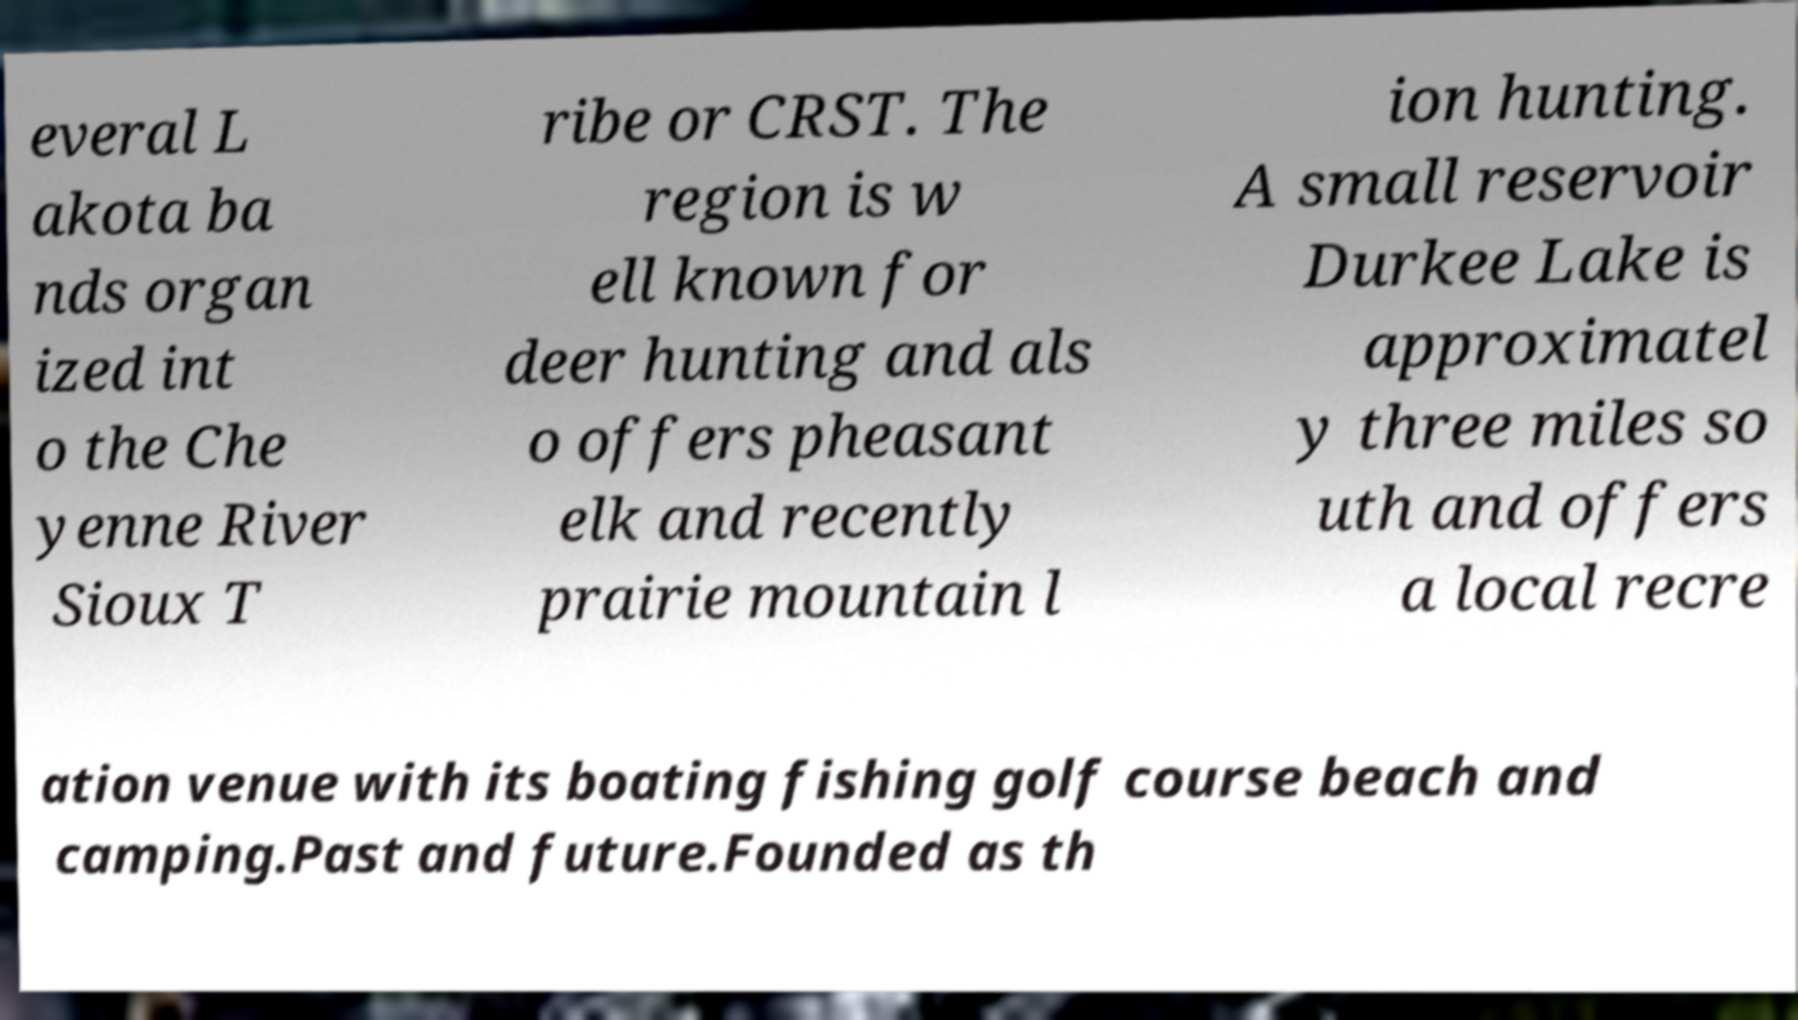Could you assist in decoding the text presented in this image and type it out clearly? everal L akota ba nds organ ized int o the Che yenne River Sioux T ribe or CRST. The region is w ell known for deer hunting and als o offers pheasant elk and recently prairie mountain l ion hunting. A small reservoir Durkee Lake is approximatel y three miles so uth and offers a local recre ation venue with its boating fishing golf course beach and camping.Past and future.Founded as th 